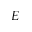<formula> <loc_0><loc_0><loc_500><loc_500>E</formula> 